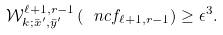<formula> <loc_0><loc_0><loc_500><loc_500>\mathcal { W } _ { k ; \bar { x } ^ { \prime } , \bar { y } ^ { \prime } } ^ { \ell + 1 , r - 1 } \left ( \ n c f _ { \ell + 1 , r - 1 } \right ) \geq \epsilon ^ { 3 } .</formula> 